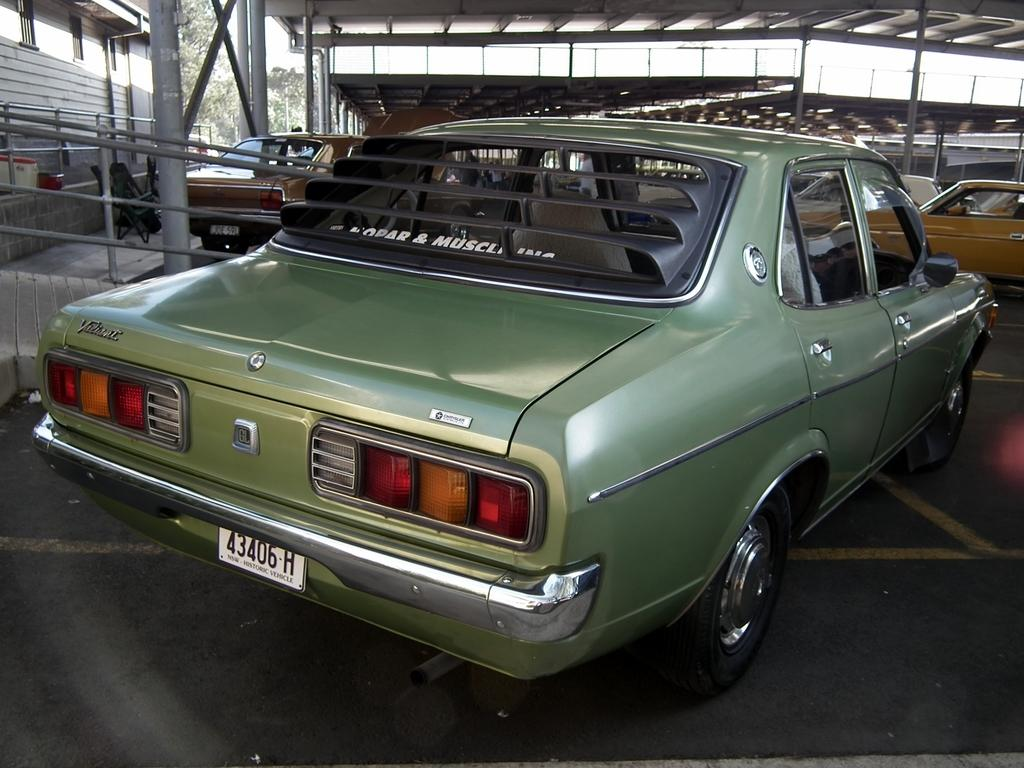What types of vehicles are on the ground in the image? The specific types of vehicles are not mentioned, but there are vehicles on the ground in the image. What kind of barrier can be seen in the image? There is a fence in the image. What structures are present in the image? There are poles in the image. What can be seen in the distance in the image? Trees are visible in the background of the image. What type of tax is being discussed in the image? There is no discussion of tax in the image; it features vehicles, a fence, poles, and trees. What amusement park can be seen in the image? There is no amusement park present in the image. 